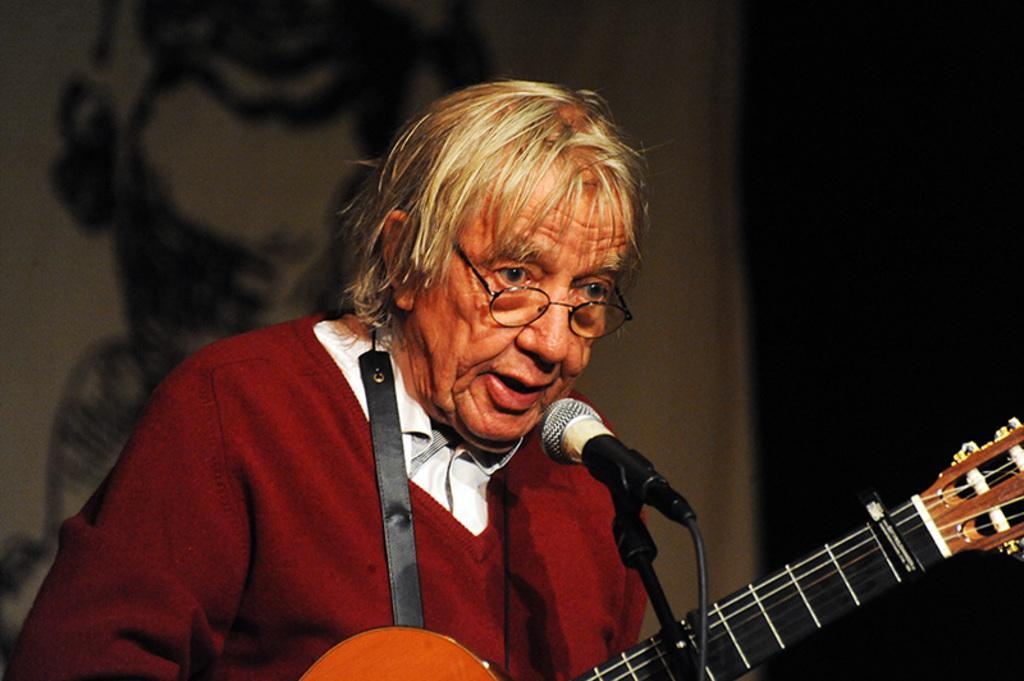Who is the main subject in the image? There is a woman in the image. What is the woman wearing? The woman is wearing a sweater and spectacles. What is the woman holding in the image? The woman is holding a guitar. What activity is the woman engaged in? The woman is singing into a microphone. What can be seen in the background of the image? There is a wall in the background of the image. What type of mitten is the woman wearing in the image? The woman is not wearing a mitten in the image; she is wearing spectacles. How deep are the roots of the tree visible in the image? There is no tree visible in the image; it features a woman singing with a guitar and a wall in the background. 